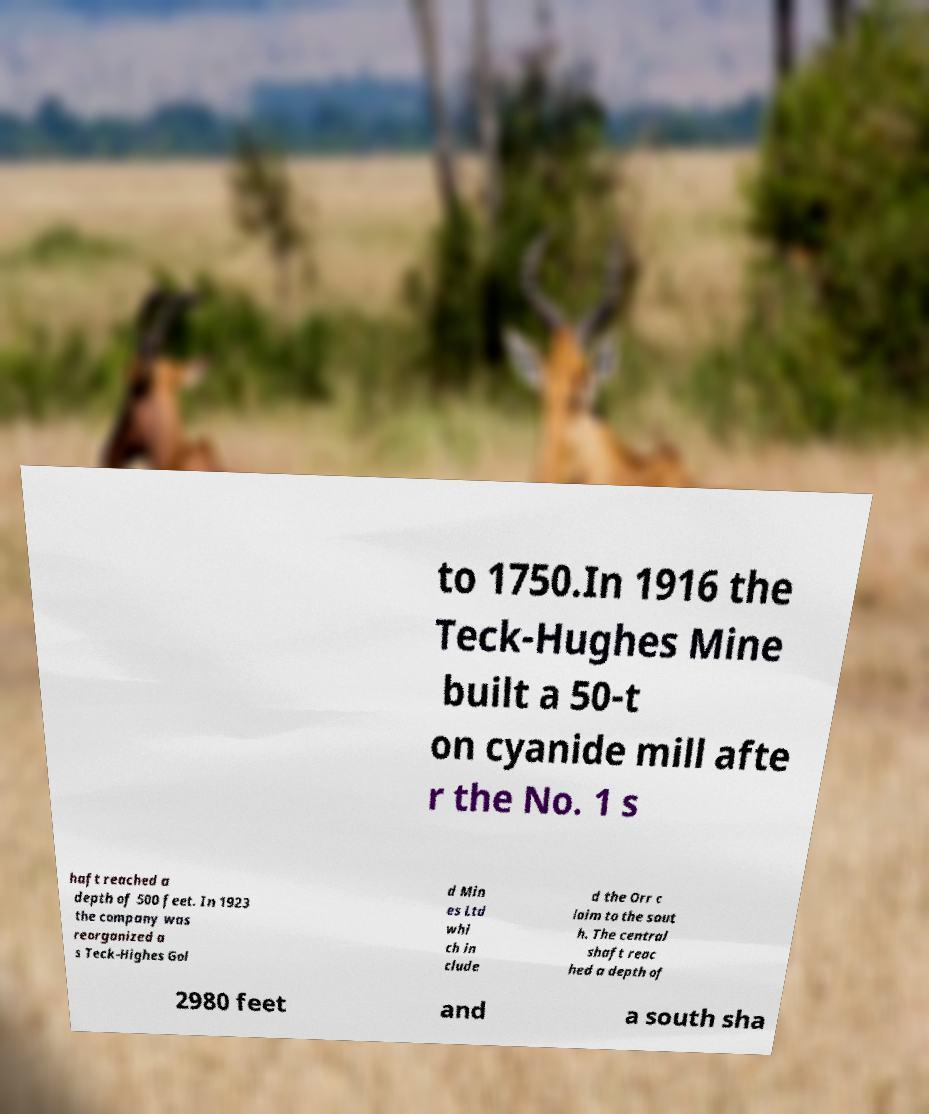Could you extract and type out the text from this image? to 1750.In 1916 the Teck-Hughes Mine built a 50-t on cyanide mill afte r the No. 1 s haft reached a depth of 500 feet. In 1923 the company was reorganized a s Teck-Highes Gol d Min es Ltd whi ch in clude d the Orr c laim to the sout h. The central shaft reac hed a depth of 2980 feet and a south sha 